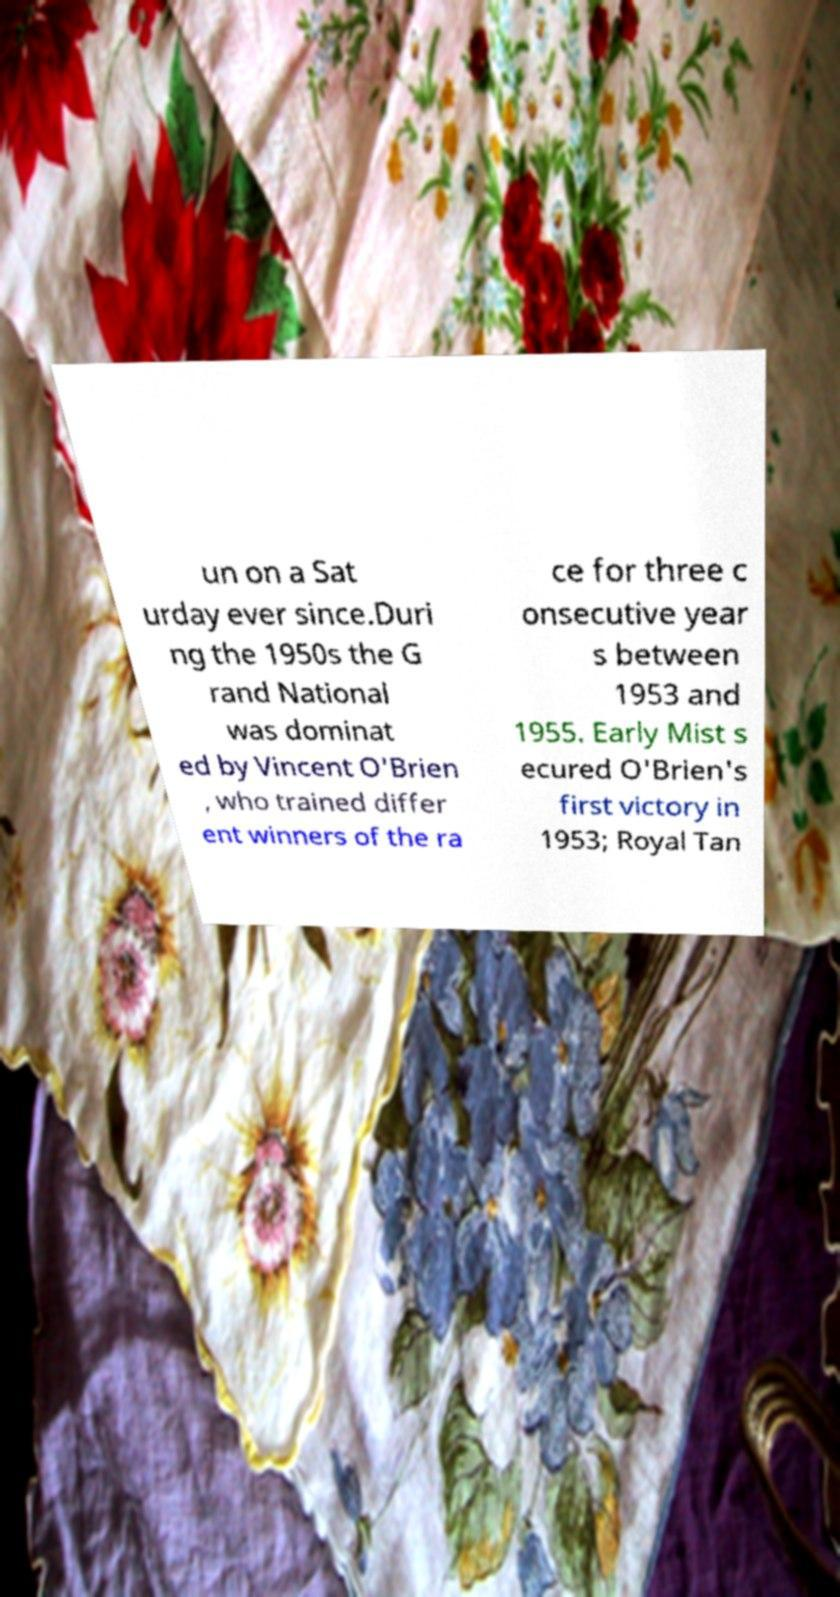I need the written content from this picture converted into text. Can you do that? un on a Sat urday ever since.Duri ng the 1950s the G rand National was dominat ed by Vincent O'Brien , who trained differ ent winners of the ra ce for three c onsecutive year s between 1953 and 1955. Early Mist s ecured O'Brien's first victory in 1953; Royal Tan 